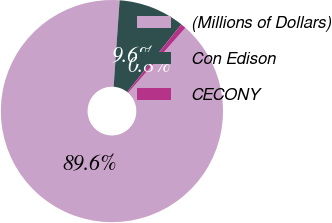<chart> <loc_0><loc_0><loc_500><loc_500><pie_chart><fcel>(Millions of Dollars)<fcel>Con Edison<fcel>CECONY<nl><fcel>89.6%<fcel>9.64%<fcel>0.76%<nl></chart> 